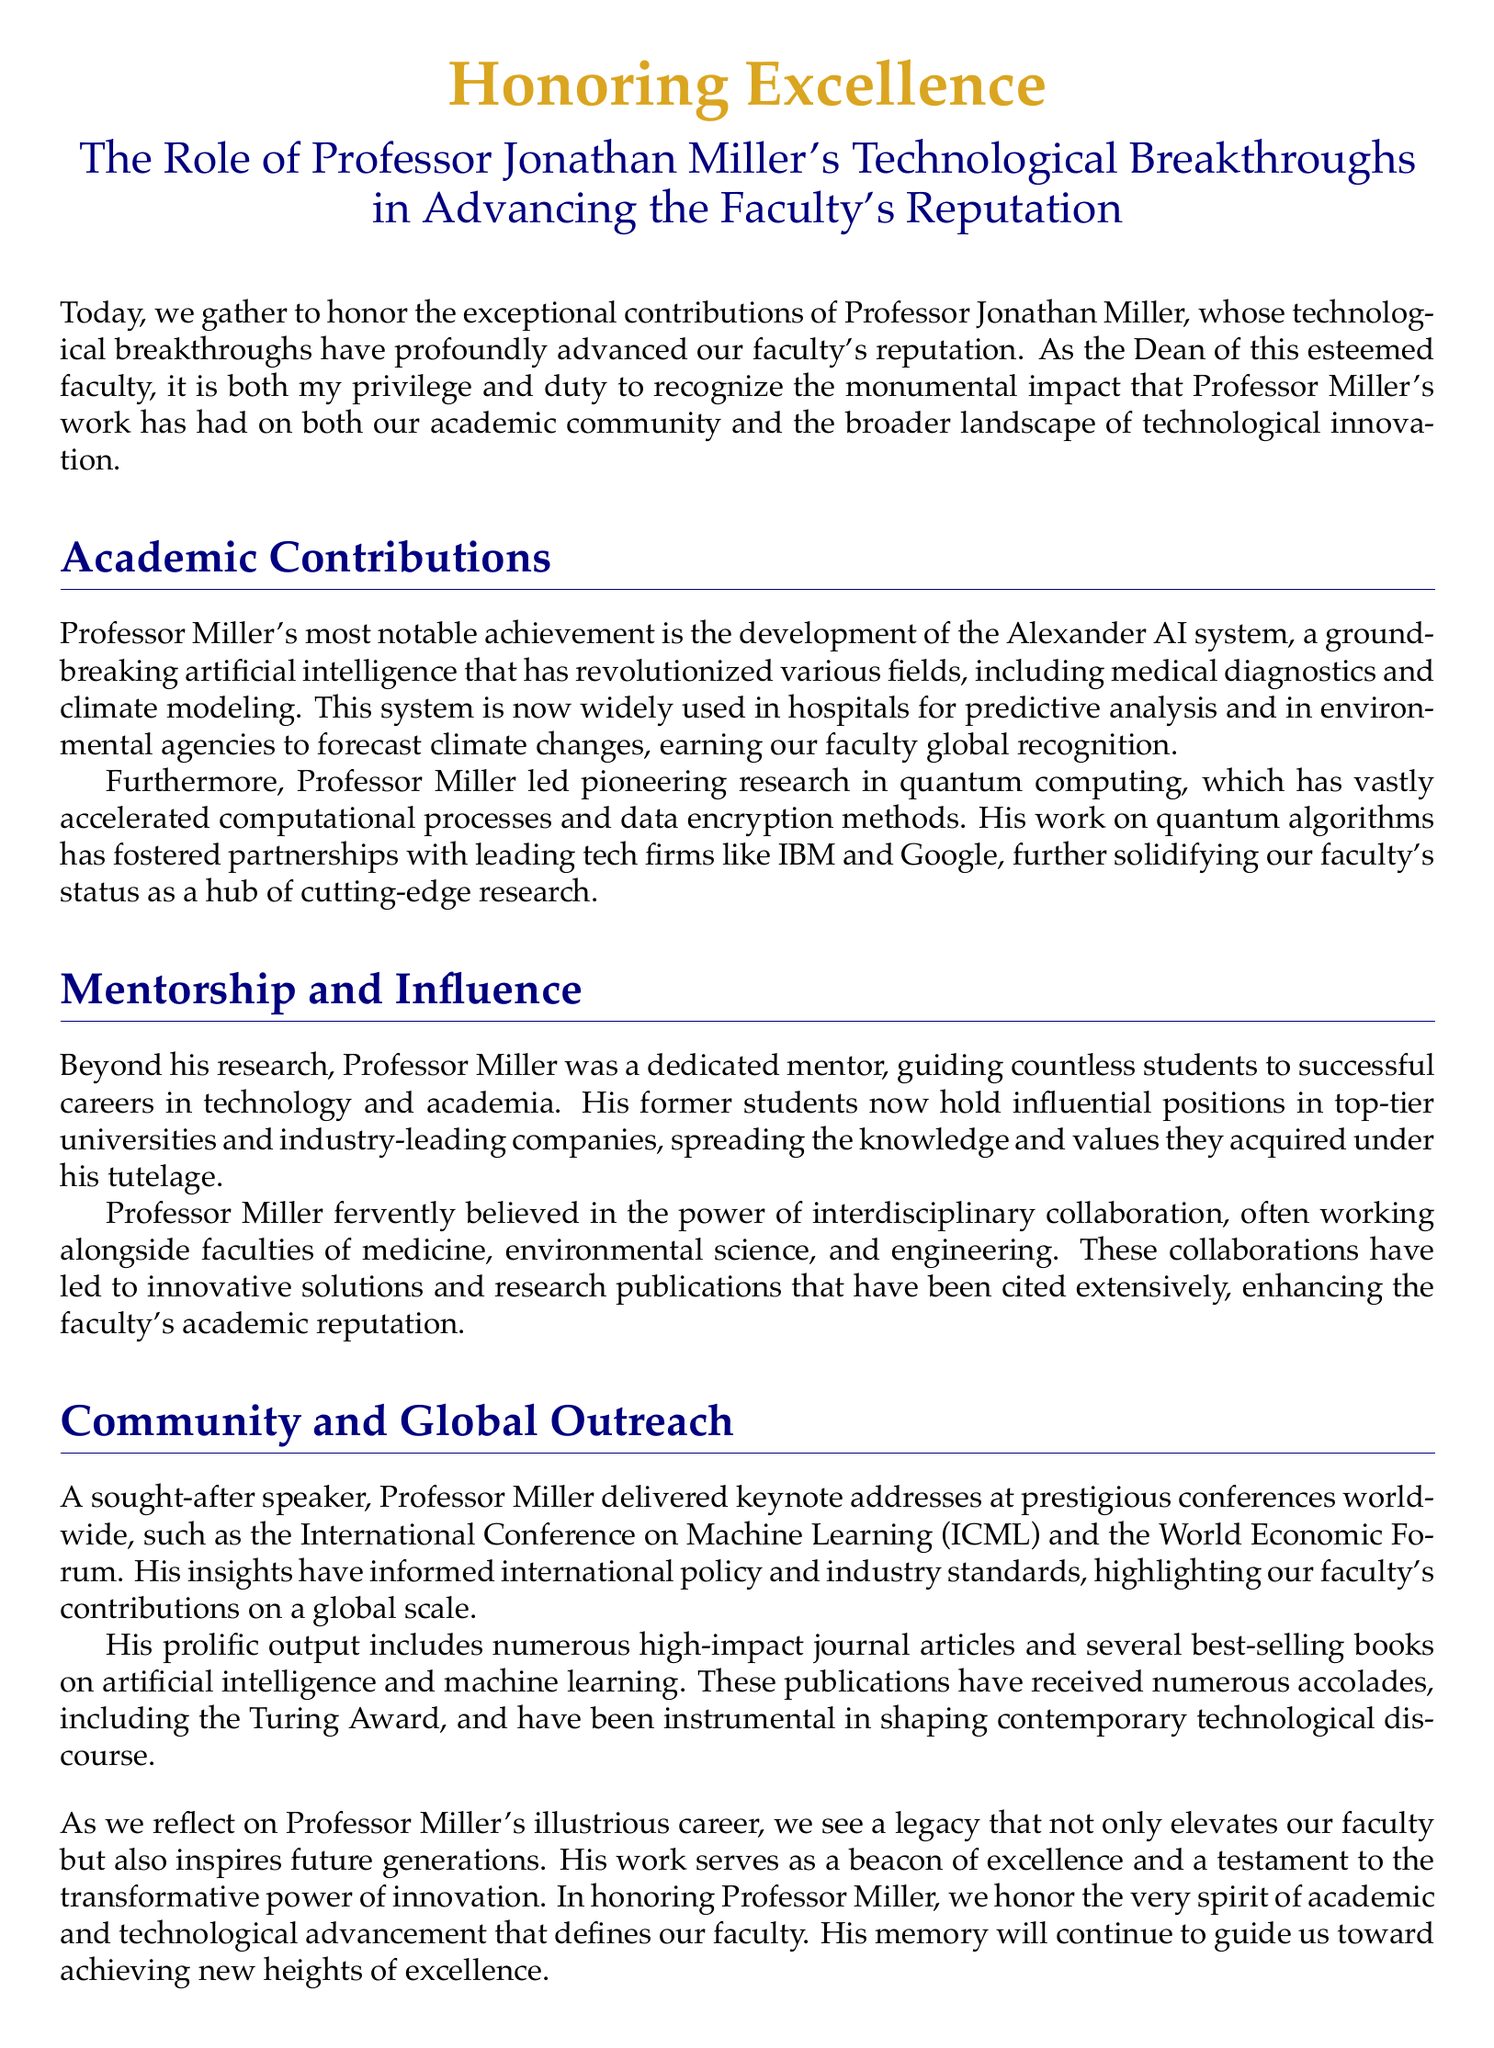What is the name of the professor being honored? The eulogy specifically mentions Professor Jonathan Miller as the person being honored for his contributions.
Answer: Jonathan Miller What technological system did Professor Miller develop? The document states that Professor Miller developed the Alexander AI system, which is highlighted as a significant achievement.
Answer: Alexander AI system Which companies partnered with Professor Miller for his research? The eulogy mentions partnerships with leading tech firms like IBM and Google related to his research in quantum computing.
Answer: IBM and Google What award did Professor Miller receive for his publications? The document notes that his publications have received numerous accolades, including the Turing Award.
Answer: Turing Award What belief did Professor Miller have about collaboration? The eulogy emphasizes that Professor Miller fervently believed in the power of interdisciplinary collaboration in his professional work.
Answer: Interdisciplinary collaboration How has Professor Miller influenced his former students? The document states that his former students now hold influential positions in top-tier universities and industry-leading companies due to his mentorship.
Answer: Influential positions What type of address did Professor Miller frequently deliver at conferences? The eulogy notes that he was a sought-after speaker who delivered keynote addresses at prestigious conferences worldwide.
Answer: Keynote addresses What impact did Professor Miller's work have on the faculty? The eulogy discusses that his work has had a profound impact on advancing the faculty's reputation through technology and research.
Answer: Advancing the faculty's reputation What is described as a legacy of Professor Miller? The document describes his legacy as something that elevates the faculty and inspires future generations through excellence and innovation.
Answer: A legacy that elevates the faculty 